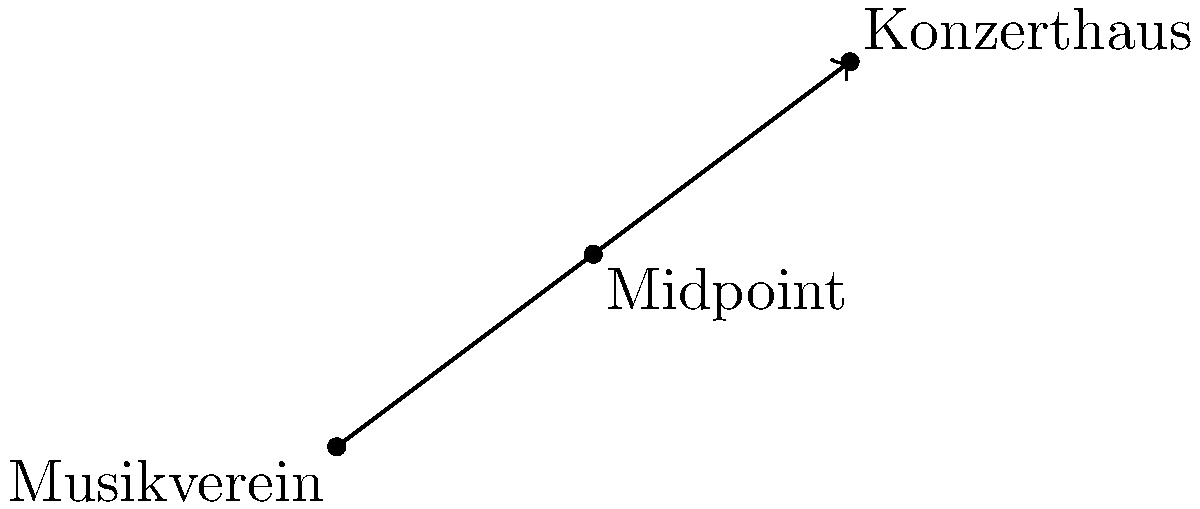As a classical music critic, you're planning to attend performances at both the Musikverein and the Konzerthaus in Vienna. On a coordinate grid representing the city map, the Musikverein is located at $(0,0)$ and the Konzerthaus at $(8,6)$. To optimize your route, you decide to meet your colleague at the midpoint between these two venues. What are the coordinates of this meeting point? To find the midpoint of a line segment, we use the midpoint formula:

$$ \text{Midpoint} = \left(\frac{x_1 + x_2}{2}, \frac{y_1 + y_2}{2}\right) $$

Where $(x_1, y_1)$ are the coordinates of the first point and $(x_2, y_2)$ are the coordinates of the second point.

1. Identify the coordinates:
   Musikverein: $(x_1, y_1) = (0, 0)$
   Konzerthaus: $(x_2, y_2) = (8, 6)$

2. Apply the midpoint formula:
   $$ x = \frac{x_1 + x_2}{2} = \frac{0 + 8}{2} = \frac{8}{2} = 4 $$
   $$ y = \frac{y_1 + y_2}{2} = \frac{0 + 6}{2} = \frac{6}{2} = 3 $$

3. Therefore, the midpoint coordinates are $(4, 3)$.

This point represents the optimal meeting location between the Musikverein and the Konzerthaus, allowing for an equal distance to both venues for your critical analysis of the performances.
Answer: $(4, 3)$ 